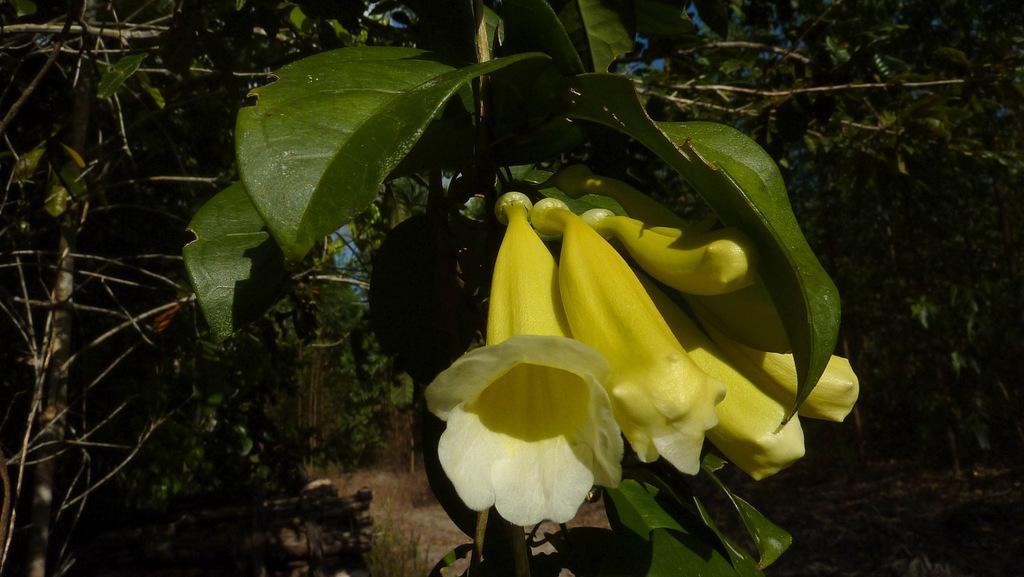Please provide a concise description of this image. This picture shows trees and we see flowers and green Leaves. Flowers are white and yellow in color. 